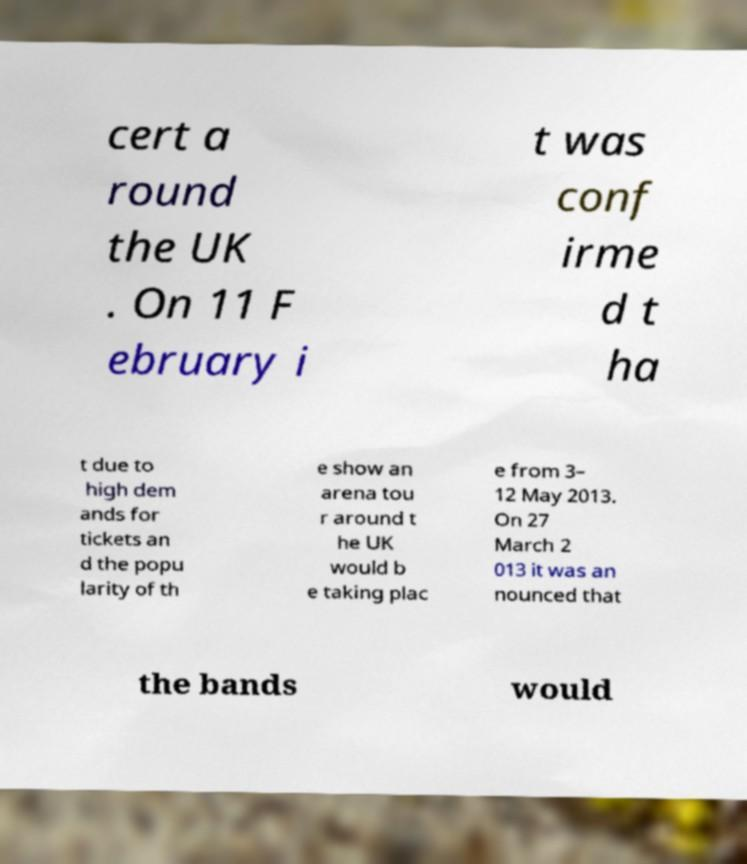I need the written content from this picture converted into text. Can you do that? cert a round the UK . On 11 F ebruary i t was conf irme d t ha t due to high dem ands for tickets an d the popu larity of th e show an arena tou r around t he UK would b e taking plac e from 3– 12 May 2013. On 27 March 2 013 it was an nounced that the bands would 